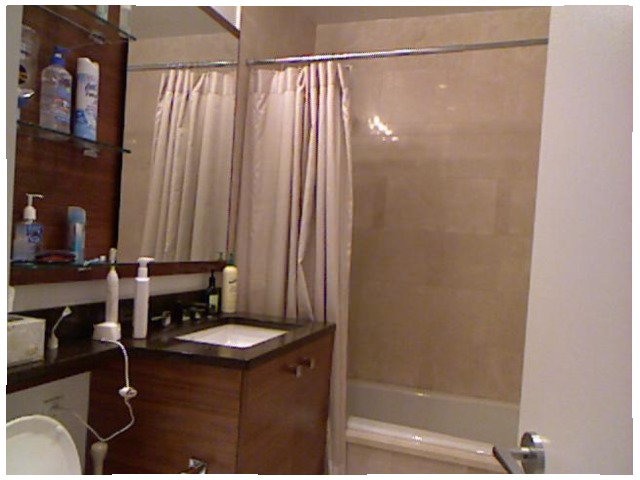<image>
Can you confirm if the curtain is to the right of the wall? No. The curtain is not to the right of the wall. The horizontal positioning shows a different relationship. Is the mirror behind the shower? No. The mirror is not behind the shower. From this viewpoint, the mirror appears to be positioned elsewhere in the scene. 